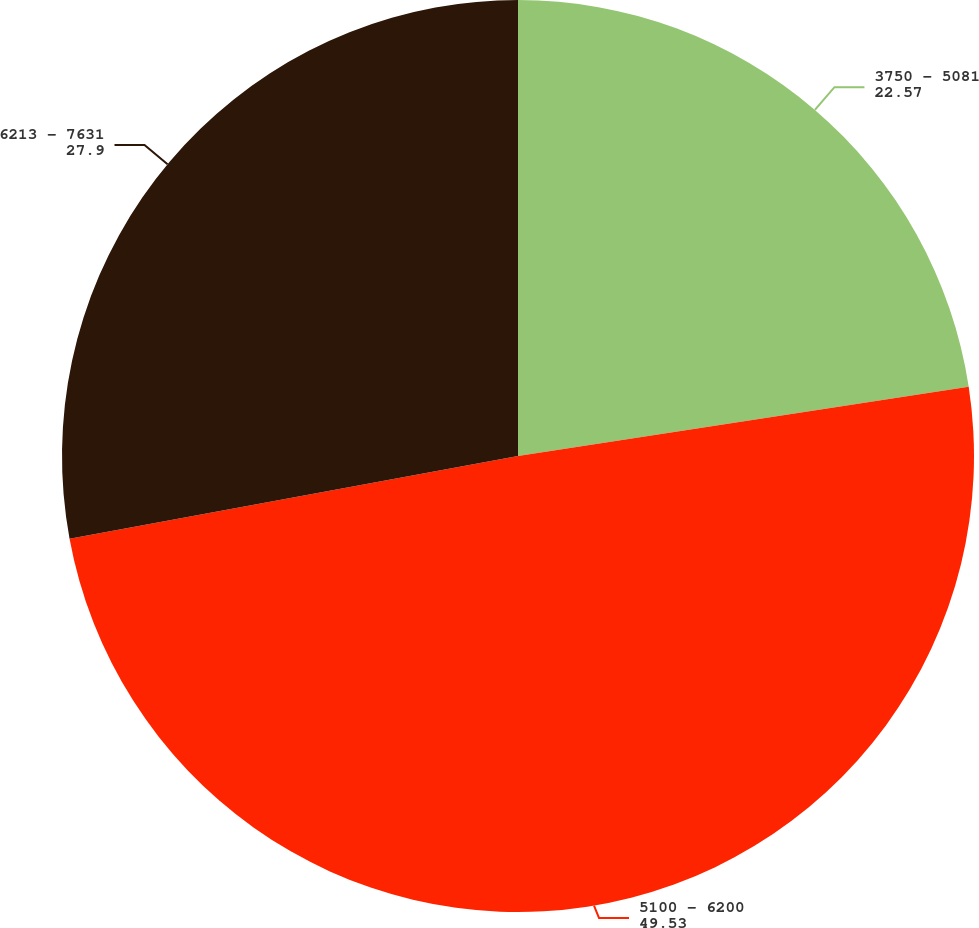<chart> <loc_0><loc_0><loc_500><loc_500><pie_chart><fcel>3750 - 5081<fcel>5100 - 6200<fcel>6213 - 7631<nl><fcel>22.57%<fcel>49.53%<fcel>27.9%<nl></chart> 